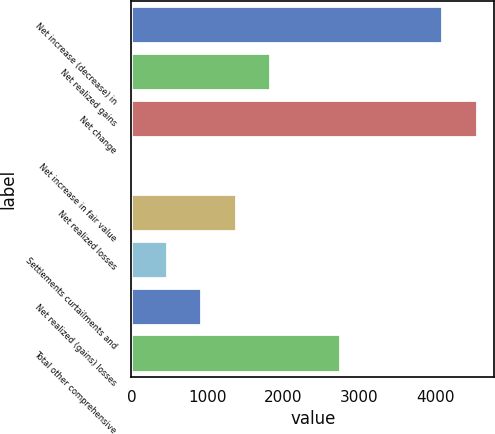Convert chart. <chart><loc_0><loc_0><loc_500><loc_500><bar_chart><fcel>Net increase (decrease) in<fcel>Net realized gains<fcel>Net change<fcel>Net increase in fair value<fcel>Net realized losses<fcel>Settlements curtailments and<fcel>Net realized (gains) losses<fcel>Total other comprehensive<nl><fcel>4077<fcel>1823.2<fcel>4540<fcel>12<fcel>1370.4<fcel>464.8<fcel>917.6<fcel>2740<nl></chart> 